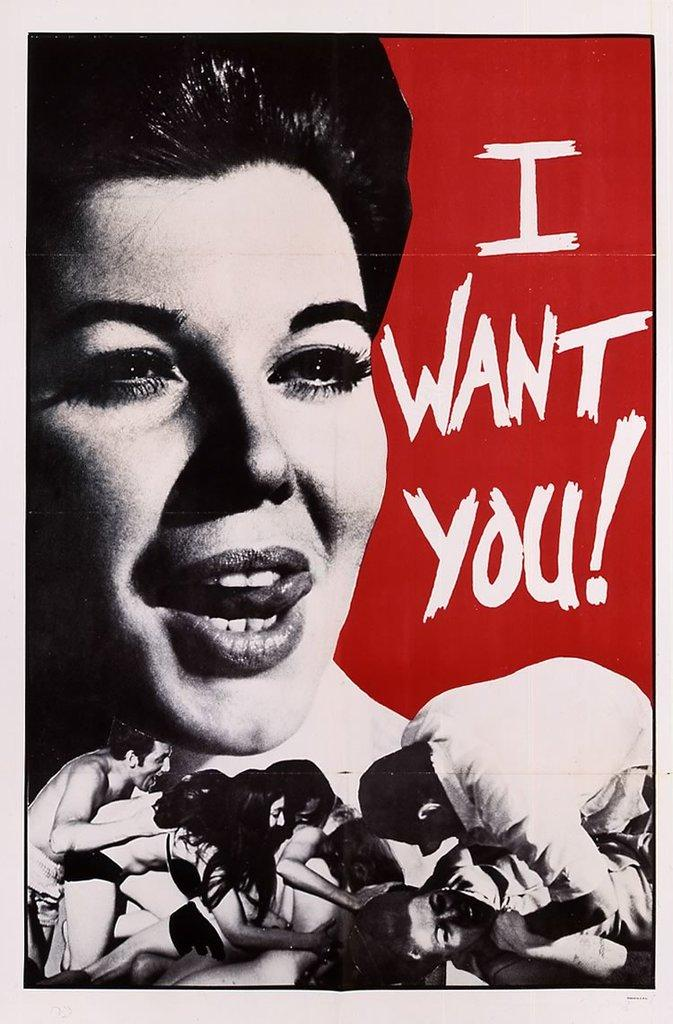<image>
Describe the image concisely. A poster of a woman with "I Want You" written next to her. 